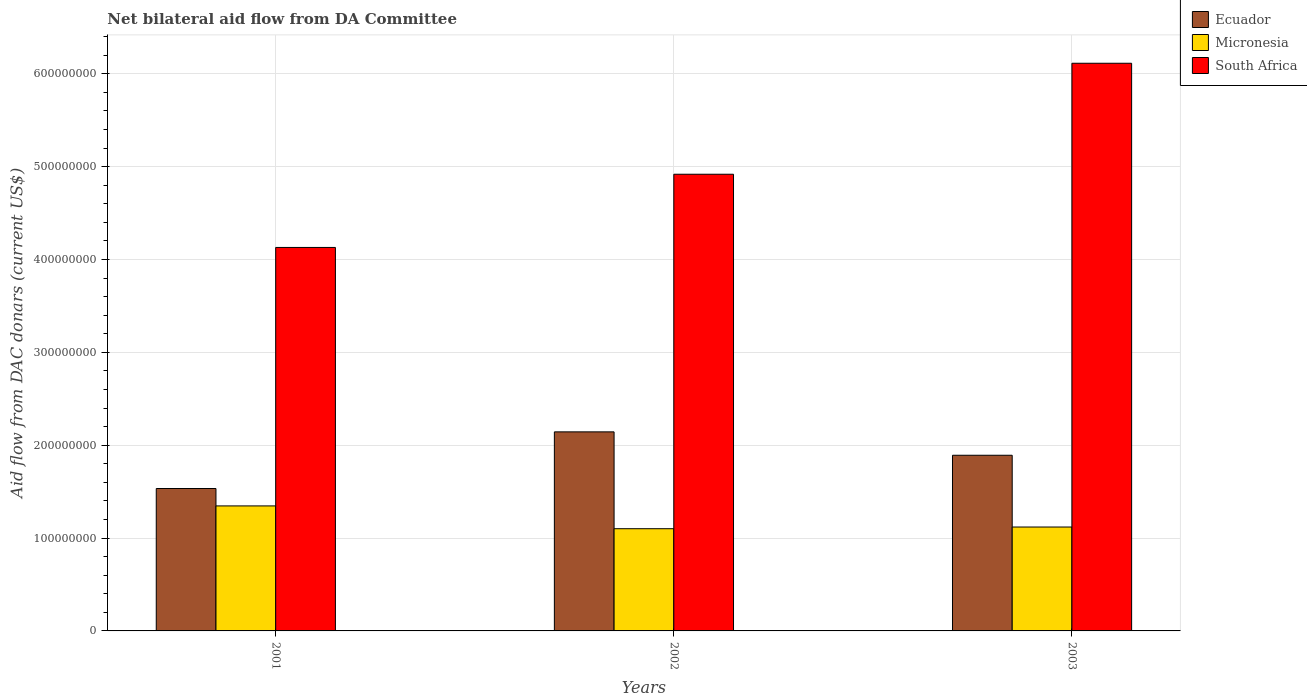Are the number of bars per tick equal to the number of legend labels?
Give a very brief answer. Yes. How many bars are there on the 2nd tick from the left?
Give a very brief answer. 3. How many bars are there on the 3rd tick from the right?
Your response must be concise. 3. What is the aid flow in in Micronesia in 2001?
Make the answer very short. 1.35e+08. Across all years, what is the maximum aid flow in in South Africa?
Provide a succinct answer. 6.11e+08. Across all years, what is the minimum aid flow in in Micronesia?
Offer a terse response. 1.10e+08. In which year was the aid flow in in Ecuador maximum?
Your answer should be compact. 2002. In which year was the aid flow in in South Africa minimum?
Make the answer very short. 2001. What is the total aid flow in in Ecuador in the graph?
Offer a very short reply. 5.57e+08. What is the difference between the aid flow in in South Africa in 2001 and that in 2003?
Your answer should be compact. -1.98e+08. What is the difference between the aid flow in in Micronesia in 2003 and the aid flow in in Ecuador in 2001?
Offer a terse response. -4.15e+07. What is the average aid flow in in South Africa per year?
Make the answer very short. 5.05e+08. In the year 2003, what is the difference between the aid flow in in Micronesia and aid flow in in South Africa?
Ensure brevity in your answer.  -4.99e+08. What is the ratio of the aid flow in in South Africa in 2002 to that in 2003?
Make the answer very short. 0.8. Is the difference between the aid flow in in Micronesia in 2001 and 2003 greater than the difference between the aid flow in in South Africa in 2001 and 2003?
Offer a terse response. Yes. What is the difference between the highest and the second highest aid flow in in Micronesia?
Offer a very short reply. 2.27e+07. What is the difference between the highest and the lowest aid flow in in Ecuador?
Make the answer very short. 6.10e+07. In how many years, is the aid flow in in South Africa greater than the average aid flow in in South Africa taken over all years?
Your answer should be compact. 1. What does the 3rd bar from the left in 2001 represents?
Provide a succinct answer. South Africa. What does the 3rd bar from the right in 2001 represents?
Provide a short and direct response. Ecuador. Is it the case that in every year, the sum of the aid flow in in Ecuador and aid flow in in South Africa is greater than the aid flow in in Micronesia?
Your answer should be compact. Yes. How many bars are there?
Give a very brief answer. 9. Are all the bars in the graph horizontal?
Make the answer very short. No. How many years are there in the graph?
Your answer should be very brief. 3. What is the difference between two consecutive major ticks on the Y-axis?
Your answer should be compact. 1.00e+08. Does the graph contain any zero values?
Make the answer very short. No. Does the graph contain grids?
Ensure brevity in your answer.  Yes. How are the legend labels stacked?
Make the answer very short. Vertical. What is the title of the graph?
Offer a very short reply. Net bilateral aid flow from DA Committee. What is the label or title of the X-axis?
Offer a terse response. Years. What is the label or title of the Y-axis?
Provide a succinct answer. Aid flow from DAC donars (current US$). What is the Aid flow from DAC donars (current US$) of Ecuador in 2001?
Ensure brevity in your answer.  1.53e+08. What is the Aid flow from DAC donars (current US$) of Micronesia in 2001?
Provide a short and direct response. 1.35e+08. What is the Aid flow from DAC donars (current US$) in South Africa in 2001?
Provide a succinct answer. 4.13e+08. What is the Aid flow from DAC donars (current US$) in Ecuador in 2002?
Provide a succinct answer. 2.14e+08. What is the Aid flow from DAC donars (current US$) of Micronesia in 2002?
Make the answer very short. 1.10e+08. What is the Aid flow from DAC donars (current US$) in South Africa in 2002?
Keep it short and to the point. 4.92e+08. What is the Aid flow from DAC donars (current US$) in Ecuador in 2003?
Offer a terse response. 1.89e+08. What is the Aid flow from DAC donars (current US$) in Micronesia in 2003?
Offer a terse response. 1.12e+08. What is the Aid flow from DAC donars (current US$) in South Africa in 2003?
Give a very brief answer. 6.11e+08. Across all years, what is the maximum Aid flow from DAC donars (current US$) in Ecuador?
Give a very brief answer. 2.14e+08. Across all years, what is the maximum Aid flow from DAC donars (current US$) of Micronesia?
Provide a succinct answer. 1.35e+08. Across all years, what is the maximum Aid flow from DAC donars (current US$) in South Africa?
Ensure brevity in your answer.  6.11e+08. Across all years, what is the minimum Aid flow from DAC donars (current US$) of Ecuador?
Offer a very short reply. 1.53e+08. Across all years, what is the minimum Aid flow from DAC donars (current US$) of Micronesia?
Offer a terse response. 1.10e+08. Across all years, what is the minimum Aid flow from DAC donars (current US$) of South Africa?
Your answer should be compact. 4.13e+08. What is the total Aid flow from DAC donars (current US$) of Ecuador in the graph?
Your response must be concise. 5.57e+08. What is the total Aid flow from DAC donars (current US$) of Micronesia in the graph?
Provide a succinct answer. 3.57e+08. What is the total Aid flow from DAC donars (current US$) of South Africa in the graph?
Provide a short and direct response. 1.52e+09. What is the difference between the Aid flow from DAC donars (current US$) in Ecuador in 2001 and that in 2002?
Your answer should be compact. -6.10e+07. What is the difference between the Aid flow from DAC donars (current US$) in Micronesia in 2001 and that in 2002?
Your answer should be very brief. 2.46e+07. What is the difference between the Aid flow from DAC donars (current US$) of South Africa in 2001 and that in 2002?
Your answer should be very brief. -7.88e+07. What is the difference between the Aid flow from DAC donars (current US$) in Ecuador in 2001 and that in 2003?
Keep it short and to the point. -3.58e+07. What is the difference between the Aid flow from DAC donars (current US$) in Micronesia in 2001 and that in 2003?
Your answer should be very brief. 2.27e+07. What is the difference between the Aid flow from DAC donars (current US$) in South Africa in 2001 and that in 2003?
Offer a very short reply. -1.98e+08. What is the difference between the Aid flow from DAC donars (current US$) of Ecuador in 2002 and that in 2003?
Ensure brevity in your answer.  2.52e+07. What is the difference between the Aid flow from DAC donars (current US$) of Micronesia in 2002 and that in 2003?
Offer a terse response. -1.82e+06. What is the difference between the Aid flow from DAC donars (current US$) in South Africa in 2002 and that in 2003?
Offer a very short reply. -1.20e+08. What is the difference between the Aid flow from DAC donars (current US$) in Ecuador in 2001 and the Aid flow from DAC donars (current US$) in Micronesia in 2002?
Your answer should be very brief. 4.33e+07. What is the difference between the Aid flow from DAC donars (current US$) in Ecuador in 2001 and the Aid flow from DAC donars (current US$) in South Africa in 2002?
Offer a terse response. -3.38e+08. What is the difference between the Aid flow from DAC donars (current US$) in Micronesia in 2001 and the Aid flow from DAC donars (current US$) in South Africa in 2002?
Ensure brevity in your answer.  -3.57e+08. What is the difference between the Aid flow from DAC donars (current US$) in Ecuador in 2001 and the Aid flow from DAC donars (current US$) in Micronesia in 2003?
Offer a terse response. 4.15e+07. What is the difference between the Aid flow from DAC donars (current US$) of Ecuador in 2001 and the Aid flow from DAC donars (current US$) of South Africa in 2003?
Make the answer very short. -4.58e+08. What is the difference between the Aid flow from DAC donars (current US$) of Micronesia in 2001 and the Aid flow from DAC donars (current US$) of South Africa in 2003?
Offer a very short reply. -4.77e+08. What is the difference between the Aid flow from DAC donars (current US$) in Ecuador in 2002 and the Aid flow from DAC donars (current US$) in Micronesia in 2003?
Give a very brief answer. 1.02e+08. What is the difference between the Aid flow from DAC donars (current US$) of Ecuador in 2002 and the Aid flow from DAC donars (current US$) of South Africa in 2003?
Your response must be concise. -3.97e+08. What is the difference between the Aid flow from DAC donars (current US$) in Micronesia in 2002 and the Aid flow from DAC donars (current US$) in South Africa in 2003?
Keep it short and to the point. -5.01e+08. What is the average Aid flow from DAC donars (current US$) of Ecuador per year?
Your answer should be very brief. 1.86e+08. What is the average Aid flow from DAC donars (current US$) in Micronesia per year?
Provide a short and direct response. 1.19e+08. What is the average Aid flow from DAC donars (current US$) of South Africa per year?
Offer a very short reply. 5.05e+08. In the year 2001, what is the difference between the Aid flow from DAC donars (current US$) of Ecuador and Aid flow from DAC donars (current US$) of Micronesia?
Your answer should be very brief. 1.88e+07. In the year 2001, what is the difference between the Aid flow from DAC donars (current US$) of Ecuador and Aid flow from DAC donars (current US$) of South Africa?
Keep it short and to the point. -2.60e+08. In the year 2001, what is the difference between the Aid flow from DAC donars (current US$) of Micronesia and Aid flow from DAC donars (current US$) of South Africa?
Your answer should be compact. -2.78e+08. In the year 2002, what is the difference between the Aid flow from DAC donars (current US$) in Ecuador and Aid flow from DAC donars (current US$) in Micronesia?
Make the answer very short. 1.04e+08. In the year 2002, what is the difference between the Aid flow from DAC donars (current US$) of Ecuador and Aid flow from DAC donars (current US$) of South Africa?
Provide a short and direct response. -2.77e+08. In the year 2002, what is the difference between the Aid flow from DAC donars (current US$) of Micronesia and Aid flow from DAC donars (current US$) of South Africa?
Give a very brief answer. -3.82e+08. In the year 2003, what is the difference between the Aid flow from DAC donars (current US$) in Ecuador and Aid flow from DAC donars (current US$) in Micronesia?
Your answer should be very brief. 7.73e+07. In the year 2003, what is the difference between the Aid flow from DAC donars (current US$) in Ecuador and Aid flow from DAC donars (current US$) in South Africa?
Give a very brief answer. -4.22e+08. In the year 2003, what is the difference between the Aid flow from DAC donars (current US$) in Micronesia and Aid flow from DAC donars (current US$) in South Africa?
Give a very brief answer. -4.99e+08. What is the ratio of the Aid flow from DAC donars (current US$) in Ecuador in 2001 to that in 2002?
Give a very brief answer. 0.72. What is the ratio of the Aid flow from DAC donars (current US$) in Micronesia in 2001 to that in 2002?
Your answer should be very brief. 1.22. What is the ratio of the Aid flow from DAC donars (current US$) in South Africa in 2001 to that in 2002?
Your answer should be very brief. 0.84. What is the ratio of the Aid flow from DAC donars (current US$) of Ecuador in 2001 to that in 2003?
Offer a terse response. 0.81. What is the ratio of the Aid flow from DAC donars (current US$) in Micronesia in 2001 to that in 2003?
Provide a succinct answer. 1.2. What is the ratio of the Aid flow from DAC donars (current US$) in South Africa in 2001 to that in 2003?
Make the answer very short. 0.68. What is the ratio of the Aid flow from DAC donars (current US$) in Ecuador in 2002 to that in 2003?
Your answer should be very brief. 1.13. What is the ratio of the Aid flow from DAC donars (current US$) in Micronesia in 2002 to that in 2003?
Keep it short and to the point. 0.98. What is the ratio of the Aid flow from DAC donars (current US$) in South Africa in 2002 to that in 2003?
Provide a short and direct response. 0.8. What is the difference between the highest and the second highest Aid flow from DAC donars (current US$) of Ecuador?
Provide a succinct answer. 2.52e+07. What is the difference between the highest and the second highest Aid flow from DAC donars (current US$) in Micronesia?
Provide a succinct answer. 2.27e+07. What is the difference between the highest and the second highest Aid flow from DAC donars (current US$) in South Africa?
Provide a succinct answer. 1.20e+08. What is the difference between the highest and the lowest Aid flow from DAC donars (current US$) in Ecuador?
Your answer should be very brief. 6.10e+07. What is the difference between the highest and the lowest Aid flow from DAC donars (current US$) of Micronesia?
Offer a terse response. 2.46e+07. What is the difference between the highest and the lowest Aid flow from DAC donars (current US$) of South Africa?
Provide a succinct answer. 1.98e+08. 